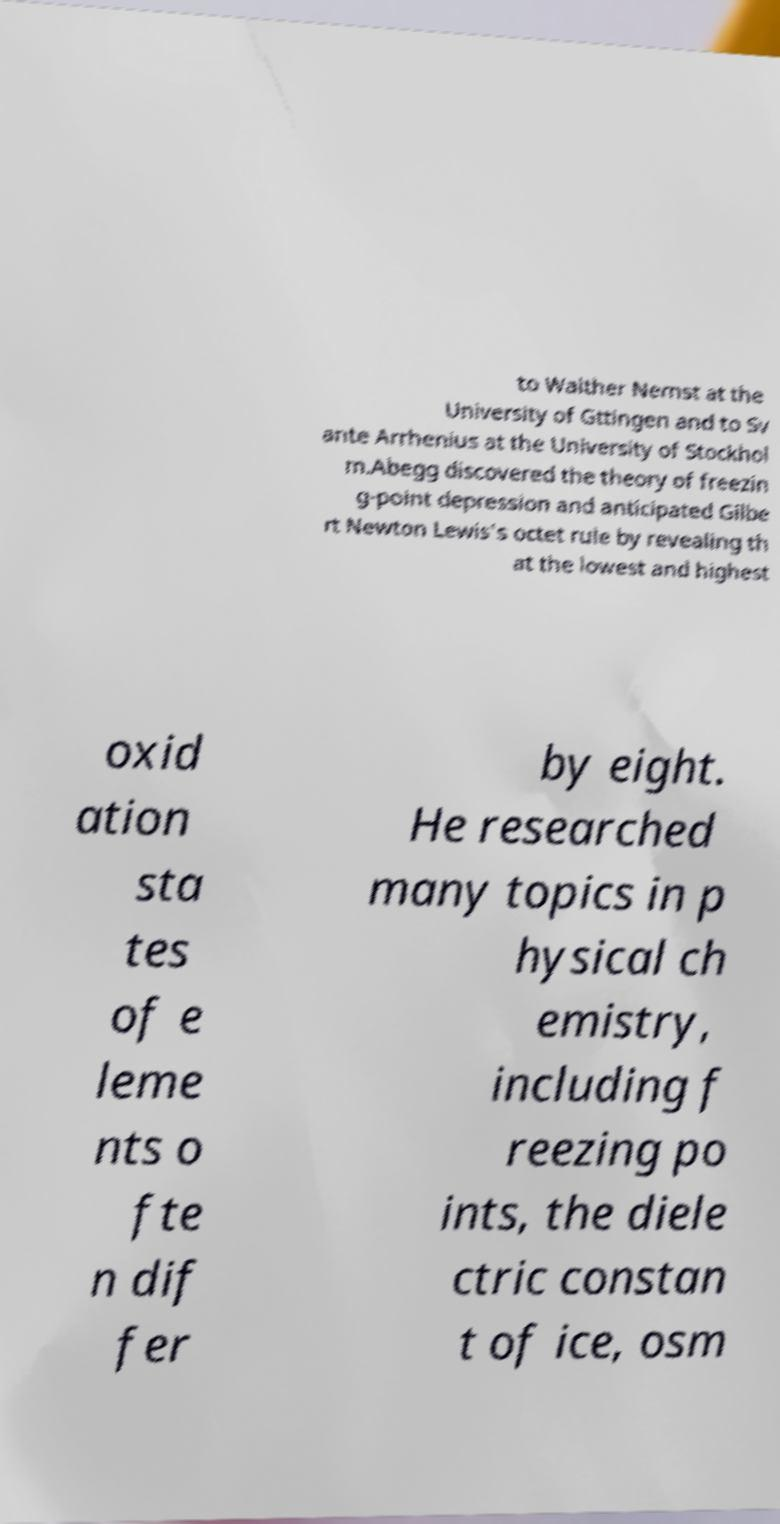Could you assist in decoding the text presented in this image and type it out clearly? to Walther Nernst at the University of Gttingen and to Sv ante Arrhenius at the University of Stockhol m.Abegg discovered the theory of freezin g-point depression and anticipated Gilbe rt Newton Lewis's octet rule by revealing th at the lowest and highest oxid ation sta tes of e leme nts o fte n dif fer by eight. He researched many topics in p hysical ch emistry, including f reezing po ints, the diele ctric constan t of ice, osm 